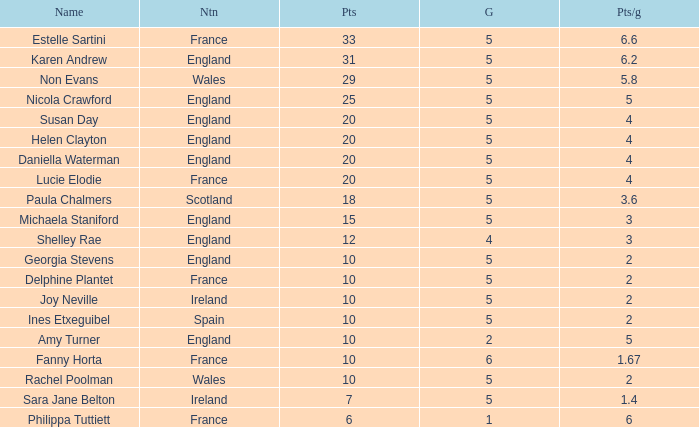Can you tell me the lowest Pts/game that has the Games larger than 6? None. 